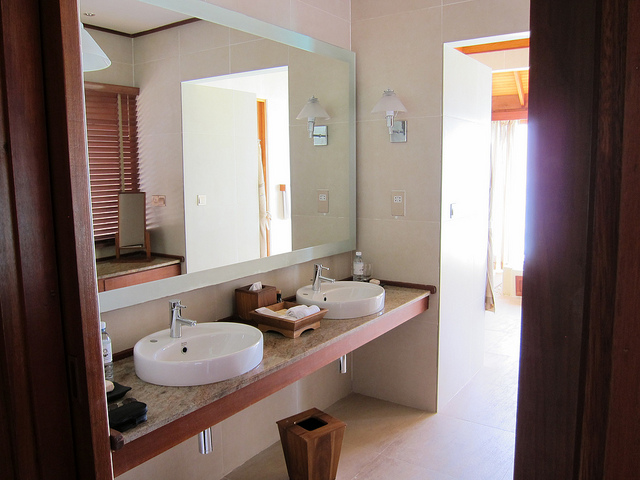What does the choice of materials and colors tell us about the overall design theme of the bathroom? The use of smooth stone for the countertops and beige wall tiles suggest a theme centered on natural beauty and durability. The colors are soft and earthy, creating a serene and inviting environment reflective of contemporary design principles that prioritize simplicity and light. 